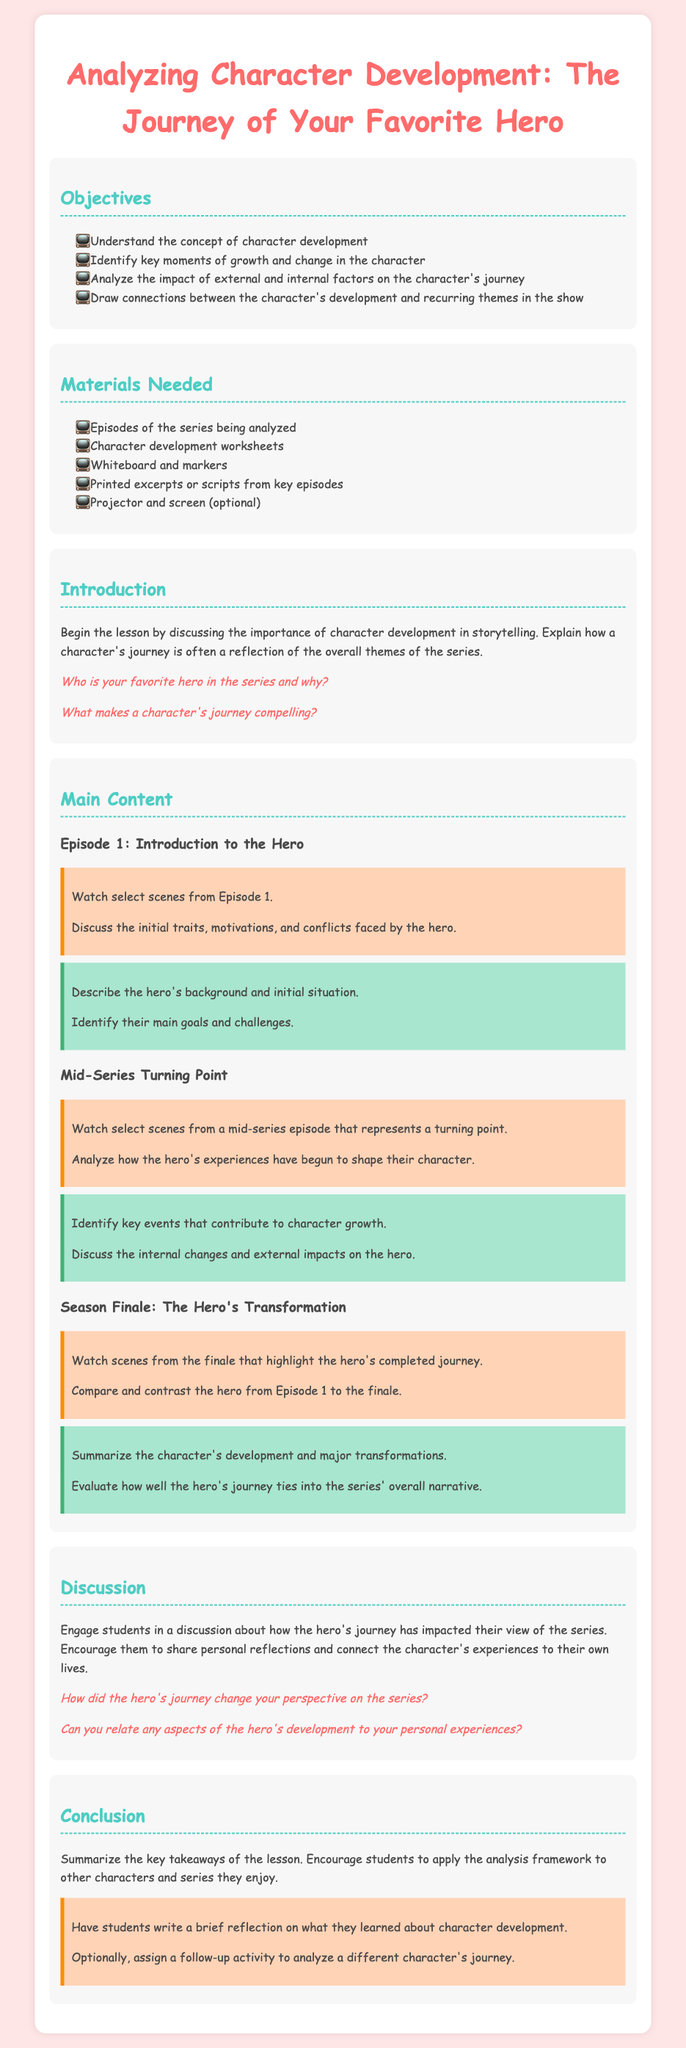what is the title of the lesson plan? The title of the lesson plan is provided at the top of the document.
Answer: Analyzing Character Development: The Journey of Your Favorite Hero how many objectives are listed in the lesson plan? The document lists the objectives in a bullet format which can be counted.
Answer: 4 what materials are needed for the lesson? The materials are specified in a section within the document.
Answer: Episodes of the series being analyzed, Character development worksheets, Whiteboard and markers, Printed excerpts or scripts from key episodes, Projector and screen (optional) what is one discussion prompt included in the introduction? The prompt asking about the favorite hero can be found in the introduction section.
Answer: Who is your favorite hero in the series and why? what is the main focus of the "Main Content" section? The "Main Content" section is centered around analyzing the hero's journey through different phases of the series.
Answer: Analyzing character development how does the lesson conclude? The conclusion summarizes key takeaways and encourages a reflection activity for students.
Answer: Summarize the key takeaways of the lesson which episode serves as the starting point for character analysis? The first episode of the series is noted as the starting point in the main content section.
Answer: Episode 1 what kind of reflections are students encouraged to write at the end of the lesson? The lesson plan specifies what students should reflect on in the conclusion.
Answer: A brief reflection on what they learned about character development 